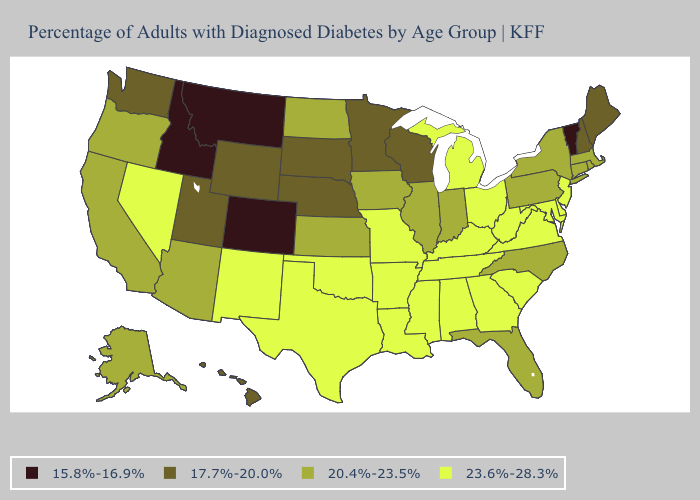Among the states that border New York , which have the highest value?
Concise answer only. New Jersey. Does Connecticut have the lowest value in the Northeast?
Be succinct. No. Which states have the lowest value in the West?
Short answer required. Colorado, Idaho, Montana. Name the states that have a value in the range 17.7%-20.0%?
Give a very brief answer. Hawaii, Maine, Minnesota, Nebraska, New Hampshire, South Dakota, Utah, Washington, Wisconsin, Wyoming. What is the lowest value in states that border Oregon?
Short answer required. 15.8%-16.9%. What is the value of Vermont?
Short answer required. 15.8%-16.9%. What is the value of Massachusetts?
Be succinct. 20.4%-23.5%. Does North Carolina have a higher value than Colorado?
Keep it brief. Yes. Which states have the lowest value in the MidWest?
Short answer required. Minnesota, Nebraska, South Dakota, Wisconsin. Does the map have missing data?
Concise answer only. No. Among the states that border Georgia , does North Carolina have the lowest value?
Give a very brief answer. Yes. Name the states that have a value in the range 17.7%-20.0%?
Short answer required. Hawaii, Maine, Minnesota, Nebraska, New Hampshire, South Dakota, Utah, Washington, Wisconsin, Wyoming. What is the highest value in states that border Pennsylvania?
Concise answer only. 23.6%-28.3%. What is the value of Louisiana?
Write a very short answer. 23.6%-28.3%. What is the value of Idaho?
Be succinct. 15.8%-16.9%. 